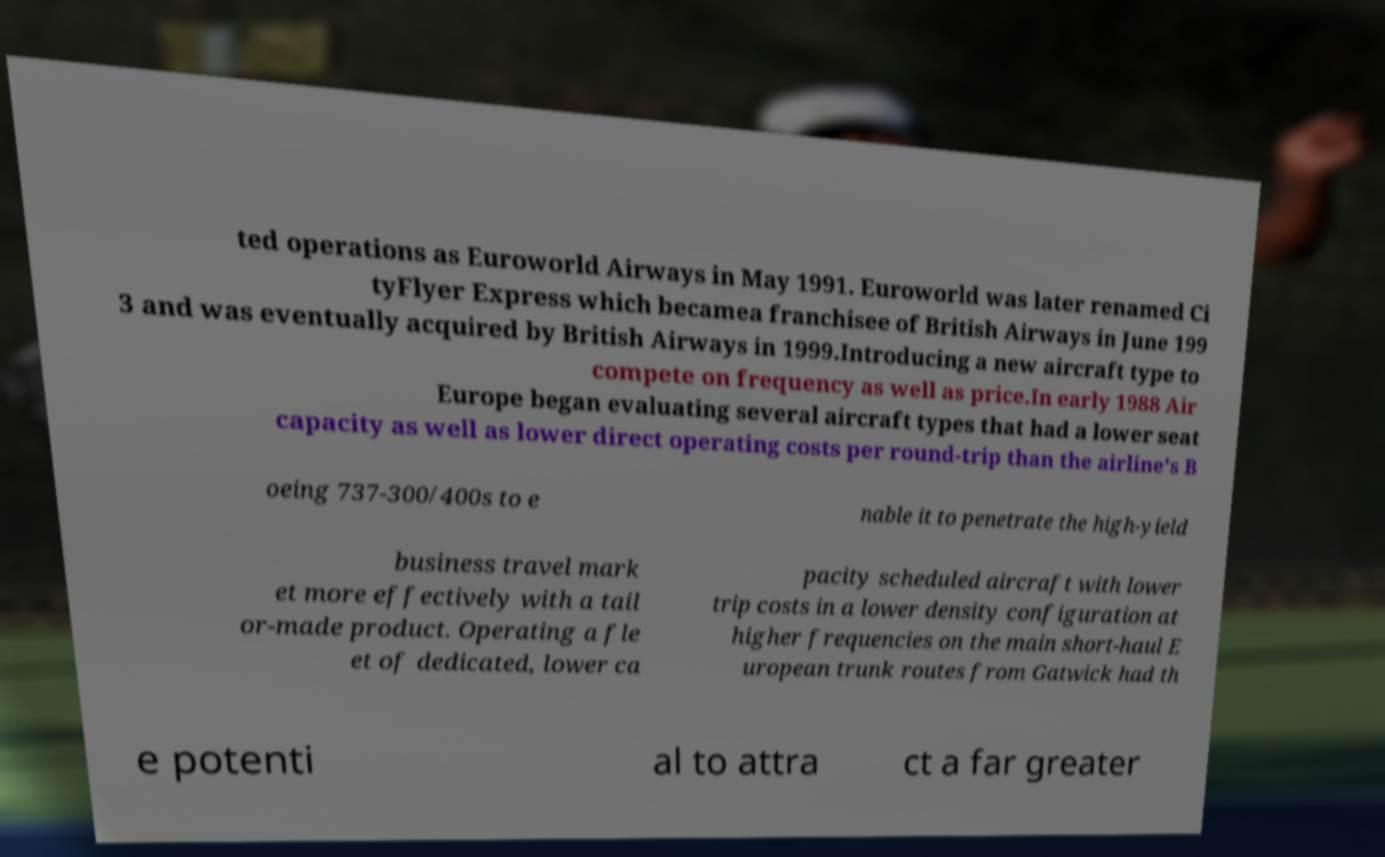Please identify and transcribe the text found in this image. ted operations as Euroworld Airways in May 1991. Euroworld was later renamed Ci tyFlyer Express which becamea franchisee of British Airways in June 199 3 and was eventually acquired by British Airways in 1999.Introducing a new aircraft type to compete on frequency as well as price.In early 1988 Air Europe began evaluating several aircraft types that had a lower seat capacity as well as lower direct operating costs per round-trip than the airline's B oeing 737-300/400s to e nable it to penetrate the high-yield business travel mark et more effectively with a tail or-made product. Operating a fle et of dedicated, lower ca pacity scheduled aircraft with lower trip costs in a lower density configuration at higher frequencies on the main short-haul E uropean trunk routes from Gatwick had th e potenti al to attra ct a far greater 